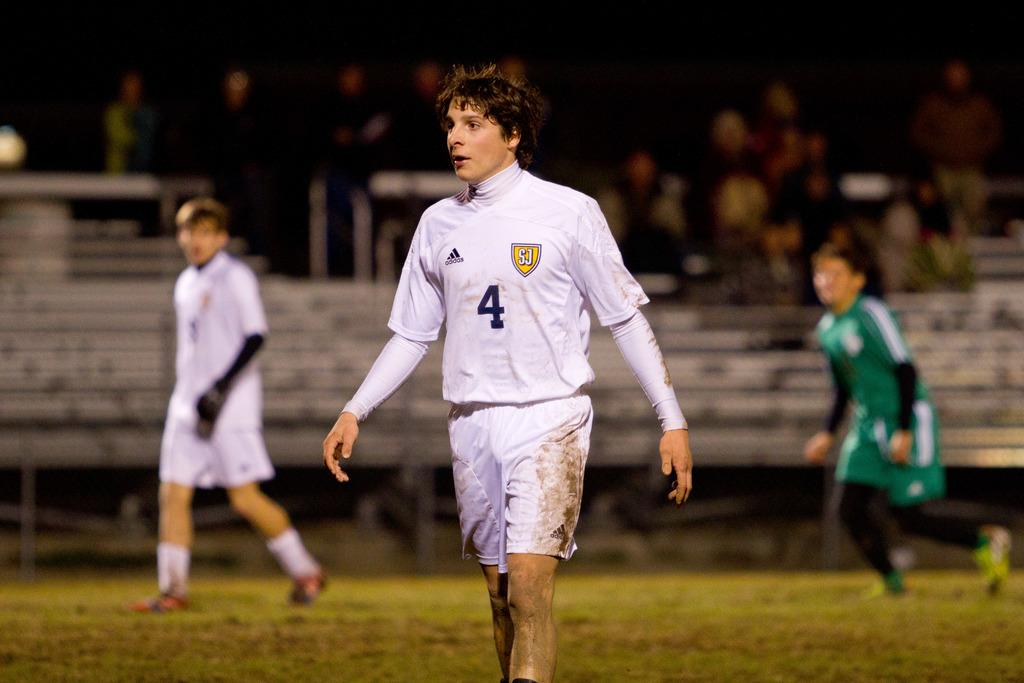What are the two people in the image doing? The two people in the image are walking on the grass. Where is the person located in the image? There is a person on the right side of the image. Can you describe the background of the image? There are people visible in the background of the image. What subject is the person on the right side of the image teaching in the image? There is no indication in the image that the person on the right side is teaching a subject. 